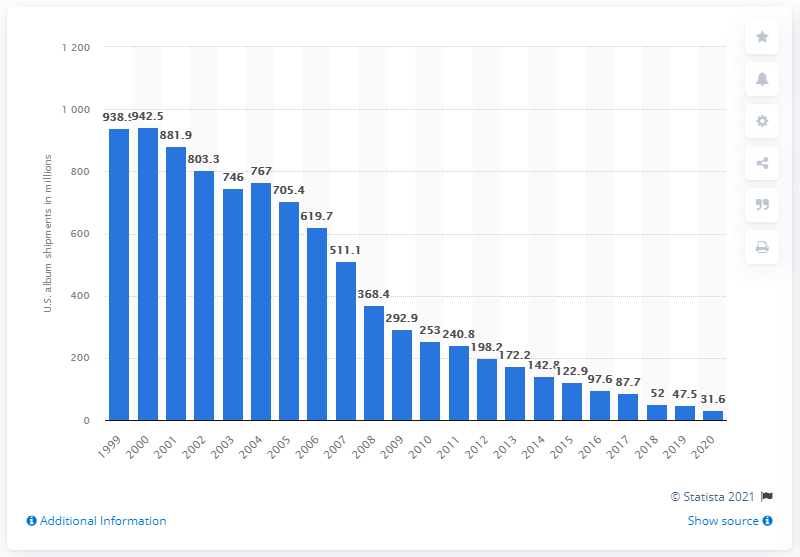Specify some key components in this picture. In 2020, a total of 31.6 million physical CDs were shipped in the United States. In the year 2000, more than 900 million CDs were shipped in the United States. 